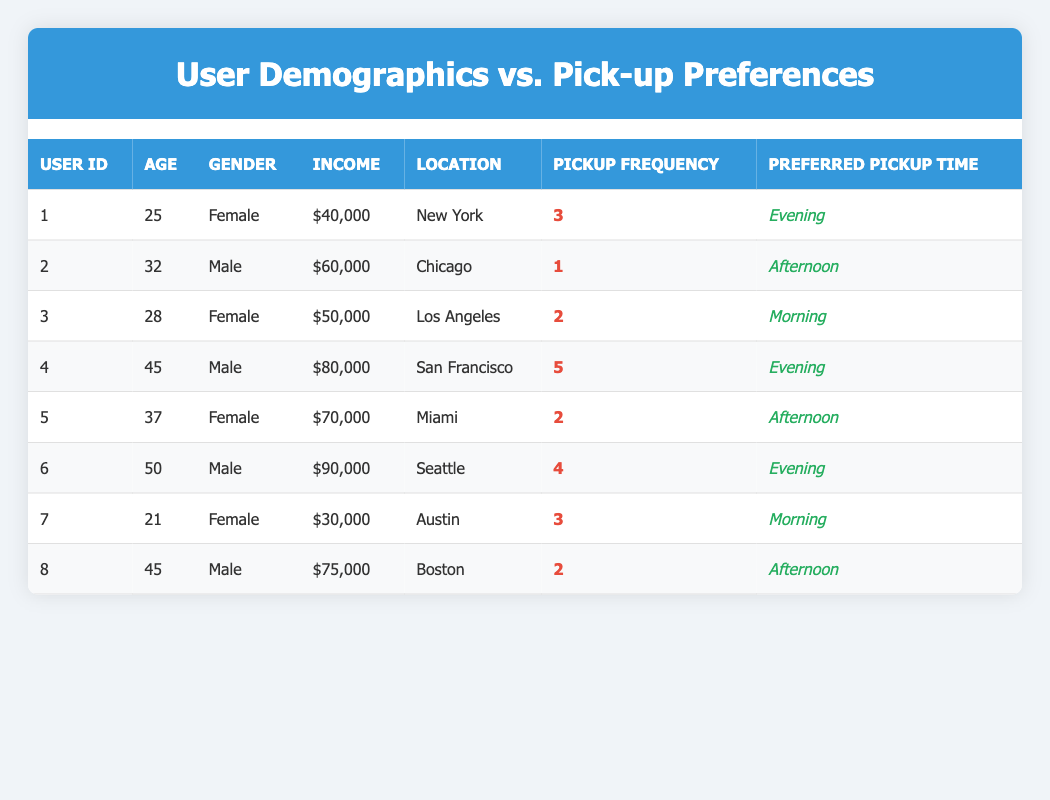What is the preferred pickup time for user ID 3? The table shows that user ID 3 has "Morning" listed as their preferred pickup time under the "Preferred Pickup Time" column.
Answer: Morning How many users have a pickup frequency of 2? Users with a pickup frequency of 2 are User ID 3, User ID 5, and User ID 8. Counting these users gives a total of 3.
Answer: 3 Is there a female user with an income of $90,000? By checking the table, there are no female users listed with an income of $90,000; User ID 6 is the only user with that income, and he is male.
Answer: No What is the average age of users who prefer evening pickups? The users who prefer evening pickups are User ID 1 (25), User ID 4 (45), and User ID 6 (50). Adding their ages gives 25 + 45 + 50 = 120. There are 3 users, so the average age is 120 / 3 = 40.
Answer: 40 Which location has the highest income among the users listed? By examining the "Income" column, User ID 6 from Seattle has the highest income of $90,000, which is greater than any other user's income listed.
Answer: Seattle What is the total pickup frequency for all users aged 45 and above? The users aged 45 and above are User ID 4 (5 pickups) and User ID 6 (4 pickups) and User ID 8 (2 pickups). Their pickup frequencies sum up to 5 + 4 + 2 = 11.
Answer: 11 Do all male users prefer afternoon pickups? Looking at male users, User ID 2 prefers afternoon, User ID 4 prefers evening, and User ID 6 prefers evening. Thus, not all male users prefer afternoon pickups.
Answer: No Which gender has the highest average income? The average income for females (User ID 1: $40,000, User ID 3: $50,000, User ID 5: $70,000) is calculated as (40,000 + 50,000 + 70,000) / 3 = $53,333. For males (User ID 2: $60,000, User ID 4: $80,000, User ID 6: $90,000) it is (60,000 + 80,000 + 90,000) / 3 = $76,666. Since $76,666 > $53,333, males have a higher average income.
Answer: Male How many users prefer 'Morning' as their preferred pickup time? The users preferring 'Morning' are User ID 3 and User ID 7. Counting these gives a total of 2 users.
Answer: 2 